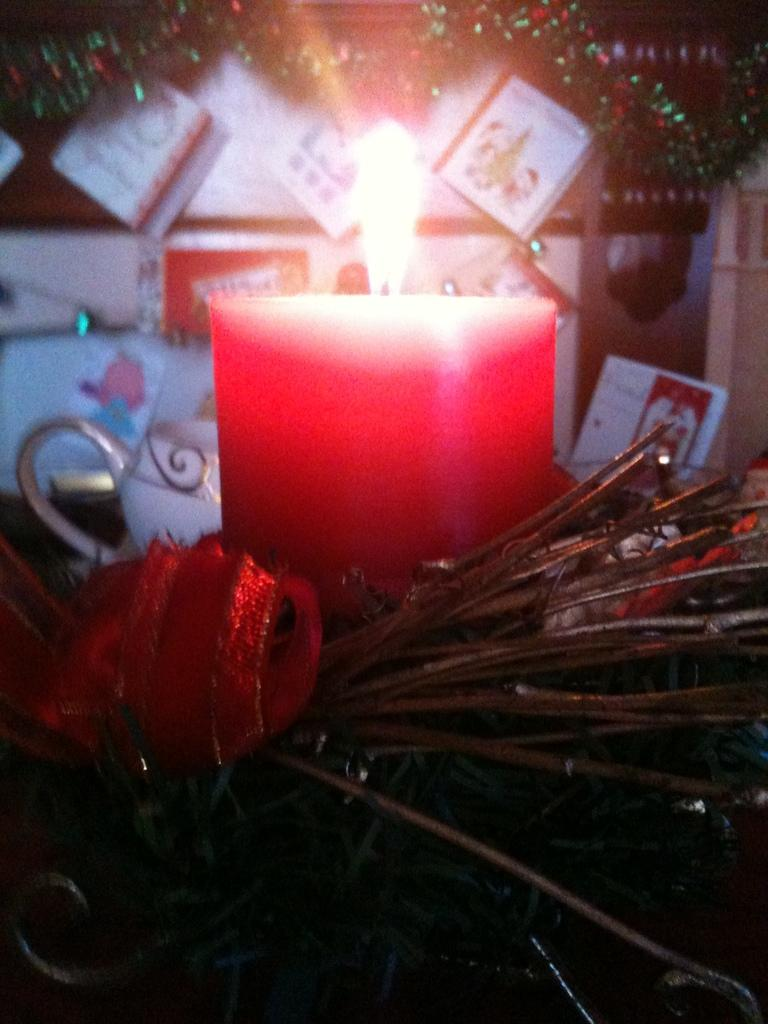What is the main object in the middle of the image? There is a candle in the middle of the image. What type of natural elements can be seen at the bottom of the image? Leaves and sticks are visible at the bottom of the image. What color is the cloth present at the bottom of the image? A red cloth is present at the bottom of the image. What can be seen attached to the wall in the background of the image? There are greeting cards attached to the wall in the background of the image. How many experts are jumping over the net in the image? There is no net or experts present in the image. What type of net can be seen in the image? There is no net present in the image. 